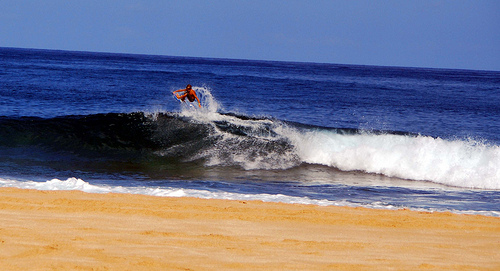Please provide a short description for this region: [0.26, 0.31, 0.64, 0.6]. Within these boundaries, we observe a surfer mid-manoeuvre, perfectly poised as the crest of a tumbling wave carries him towards the sun-kissed shore, capturing the spirit of marine adventure. 